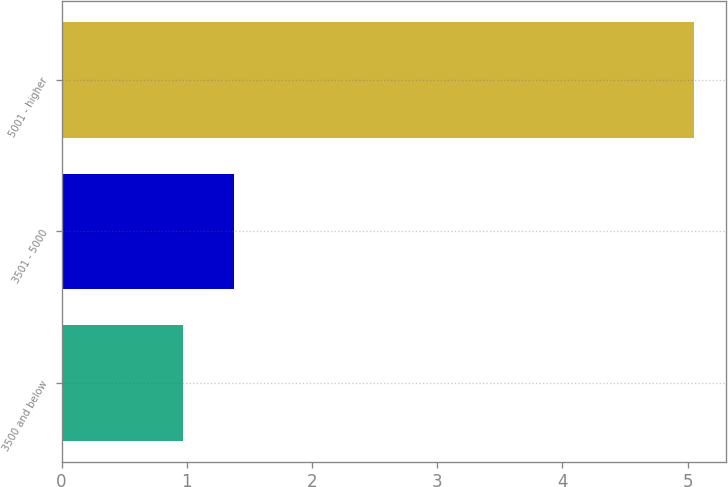Convert chart. <chart><loc_0><loc_0><loc_500><loc_500><bar_chart><fcel>3500 and below<fcel>3501 - 5000<fcel>5001 - higher<nl><fcel>0.97<fcel>1.38<fcel>5.05<nl></chart> 